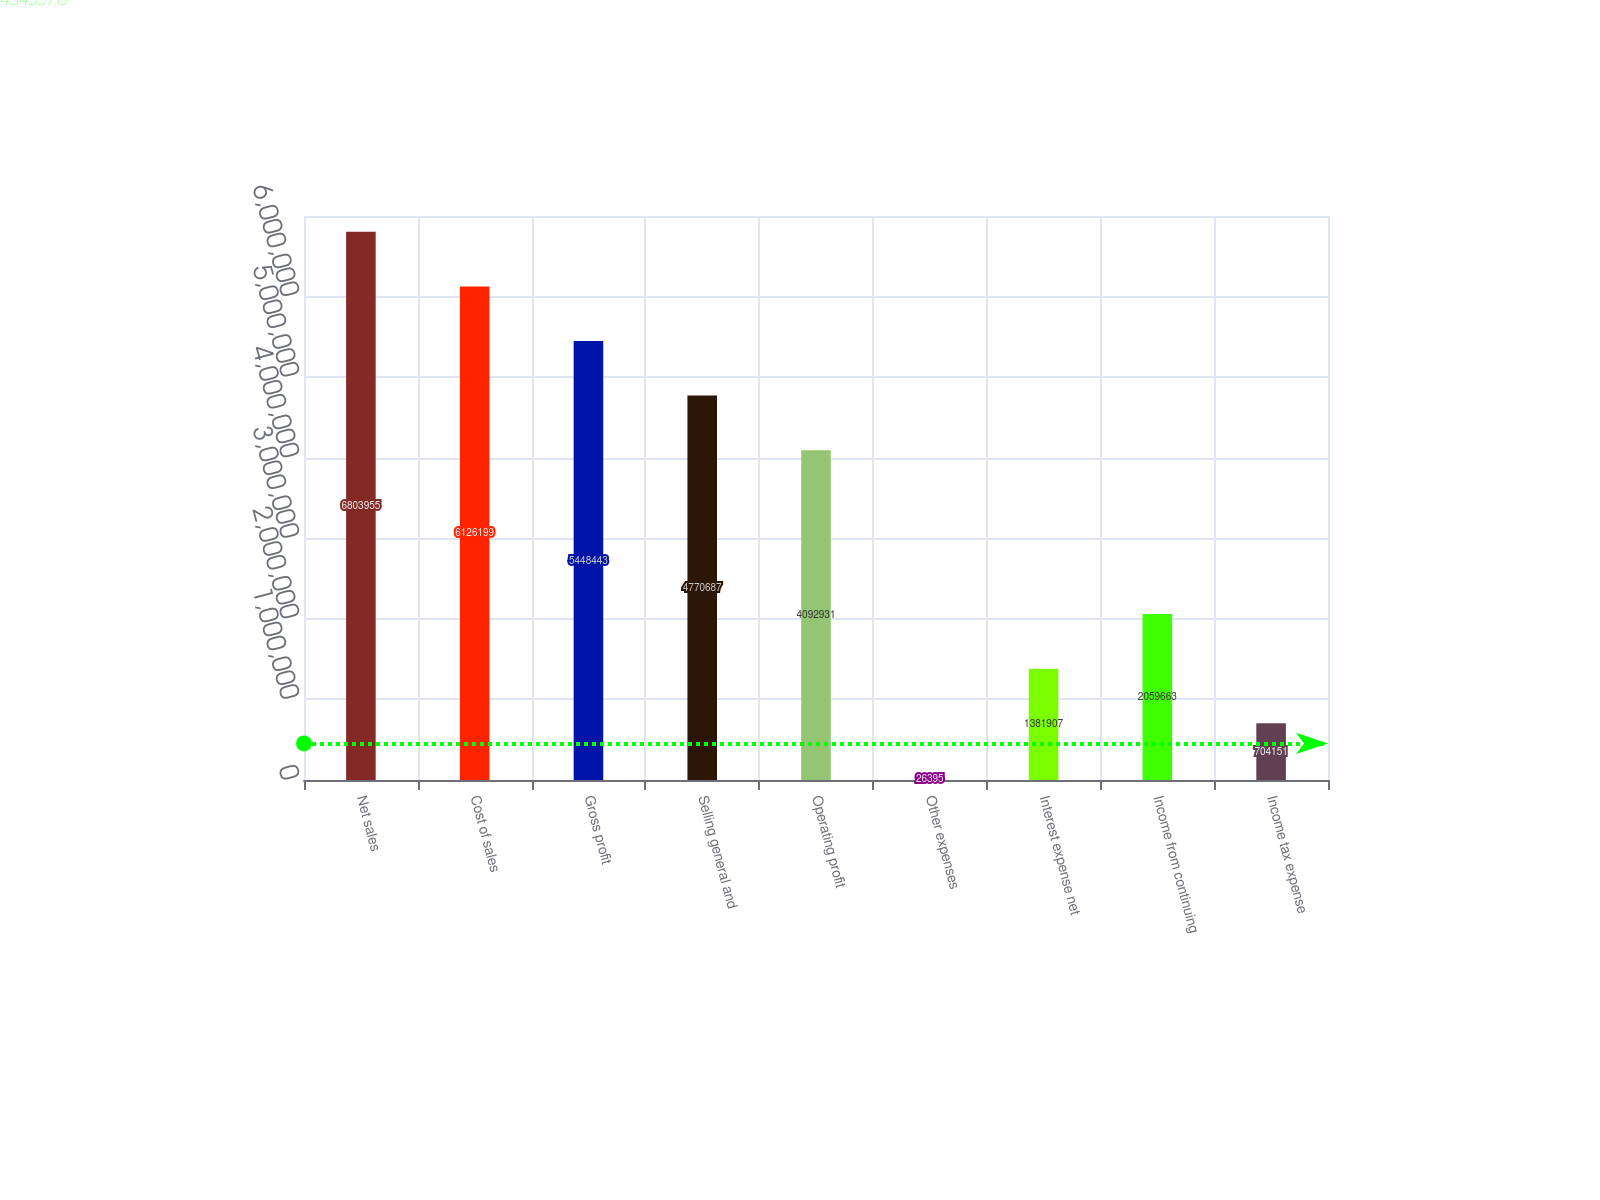Convert chart to OTSL. <chart><loc_0><loc_0><loc_500><loc_500><bar_chart><fcel>Net sales<fcel>Cost of sales<fcel>Gross profit<fcel>Selling general and<fcel>Operating profit<fcel>Other expenses<fcel>Interest expense net<fcel>Income from continuing<fcel>Income tax expense<nl><fcel>6.80396e+06<fcel>6.1262e+06<fcel>5.44844e+06<fcel>4.77069e+06<fcel>4.09293e+06<fcel>26395<fcel>1.38191e+06<fcel>2.05966e+06<fcel>704151<nl></chart> 